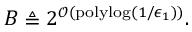Convert formula to latex. <formula><loc_0><loc_0><loc_500><loc_500>B \triangle q 2 ^ { \mathcal { O } ( p o l y \log ( 1 / \epsilon _ { 1 } ) ) } .</formula> 